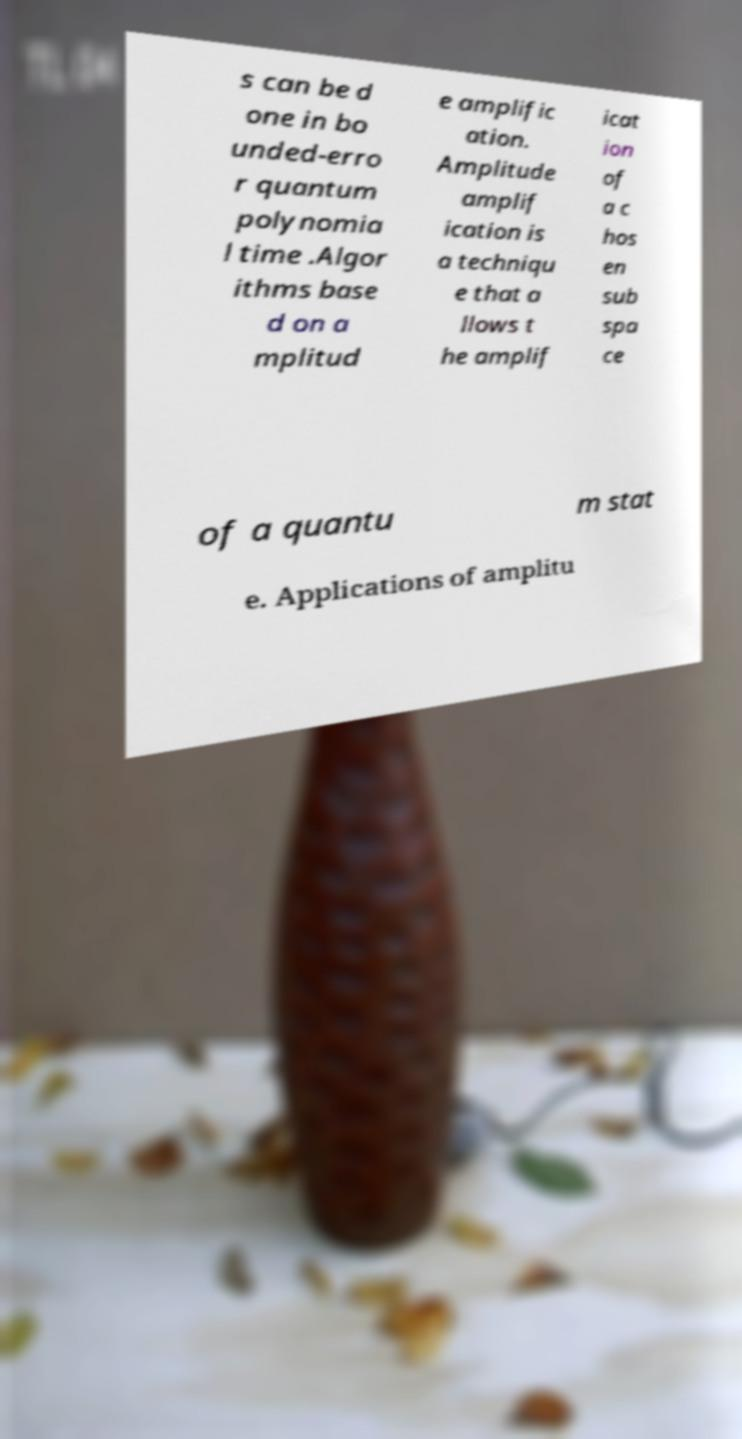Could you assist in decoding the text presented in this image and type it out clearly? s can be d one in bo unded-erro r quantum polynomia l time .Algor ithms base d on a mplitud e amplific ation. Amplitude amplif ication is a techniqu e that a llows t he amplif icat ion of a c hos en sub spa ce of a quantu m stat e. Applications of amplitu 